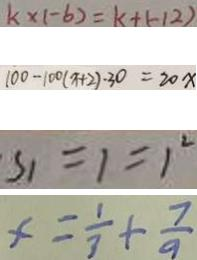Convert formula to latex. <formula><loc_0><loc_0><loc_500><loc_500>k \times ( - 6 ) = k + ( - 1 2 ) 
 1 0 0 - 1 0 0 ( x + 2 ) \cdot 3 0 = 2 0 x 
 S _ { 1 } = 1 = 1 ^ { 2 } 
 x = \frac { 1 } { 3 } + \frac { 7 } { 9 }</formula> 